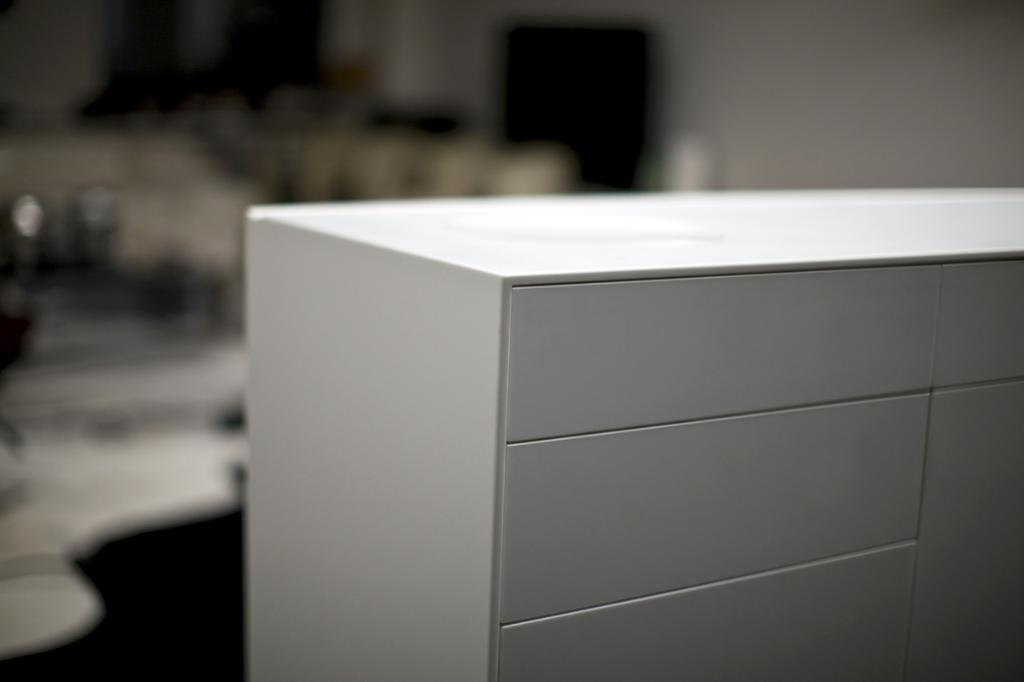What is the main object in the foreground of the image? There is a desk in the foreground of the image. What can be seen in the background of the image? There is a wall and a television in the background of the image. Are there any other objects visible in the background? Yes, there are other objects visible in the background of the image. How many friends are sitting on the desk in the image? There are no friends sitting on the desk in the image; the desk is the main object in the foreground. 